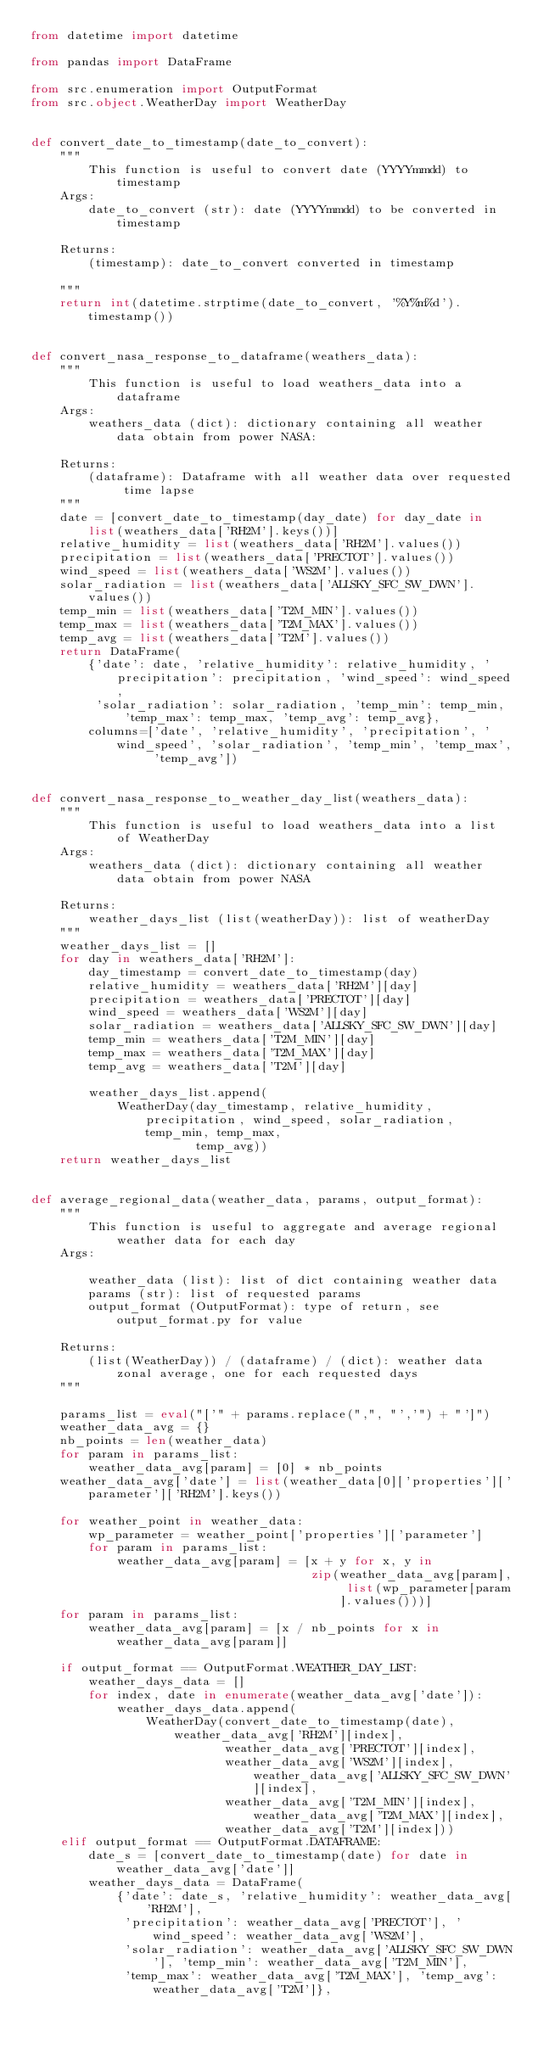<code> <loc_0><loc_0><loc_500><loc_500><_Python_>from datetime import datetime

from pandas import DataFrame

from src.enumeration import OutputFormat
from src.object.WeatherDay import WeatherDay


def convert_date_to_timestamp(date_to_convert):
    """
        This function is useful to convert date (YYYYmmdd) to timestamp
    Args:
        date_to_convert (str): date (YYYYmmdd) to be converted in timestamp

    Returns:
        (timestamp): date_to_convert converted in timestamp

    """
    return int(datetime.strptime(date_to_convert, '%Y%m%d').timestamp())


def convert_nasa_response_to_dataframe(weathers_data):
    """
        This function is useful to load weathers_data into a dataframe
    Args:
        weathers_data (dict): dictionary containing all weather data obtain from power NASA:

    Returns:
        (dataframe): Dataframe with all weather data over requested time lapse
    """
    date = [convert_date_to_timestamp(day_date) for day_date in list(weathers_data['RH2M'].keys())]
    relative_humidity = list(weathers_data['RH2M'].values())
    precipitation = list(weathers_data['PRECTOT'].values())
    wind_speed = list(weathers_data['WS2M'].values())
    solar_radiation = list(weathers_data['ALLSKY_SFC_SW_DWN'].values())
    temp_min = list(weathers_data['T2M_MIN'].values())
    temp_max = list(weathers_data['T2M_MAX'].values())
    temp_avg = list(weathers_data['T2M'].values())
    return DataFrame(
        {'date': date, 'relative_humidity': relative_humidity, 'precipitation': precipitation, 'wind_speed': wind_speed,
         'solar_radiation': solar_radiation, 'temp_min': temp_min, 'temp_max': temp_max, 'temp_avg': temp_avg},
        columns=['date', 'relative_humidity', 'precipitation', 'wind_speed', 'solar_radiation', 'temp_min', 'temp_max',
                 'temp_avg'])


def convert_nasa_response_to_weather_day_list(weathers_data):
    """
        This function is useful to load weathers_data into a list of WeatherDay
    Args:
        weathers_data (dict): dictionary containing all weather data obtain from power NASA

    Returns:
        weather_days_list (list(weatherDay)): list of weatherDay
    """
    weather_days_list = []
    for day in weathers_data['RH2M']:
        day_timestamp = convert_date_to_timestamp(day)
        relative_humidity = weathers_data['RH2M'][day]
        precipitation = weathers_data['PRECTOT'][day]
        wind_speed = weathers_data['WS2M'][day]
        solar_radiation = weathers_data['ALLSKY_SFC_SW_DWN'][day]
        temp_min = weathers_data['T2M_MIN'][day]
        temp_max = weathers_data['T2M_MAX'][day]
        temp_avg = weathers_data['T2M'][day]

        weather_days_list.append(
            WeatherDay(day_timestamp, relative_humidity, precipitation, wind_speed, solar_radiation, temp_min, temp_max,
                       temp_avg))
    return weather_days_list


def average_regional_data(weather_data, params, output_format):
    """
        This function is useful to aggregate and average regional weather data for each day
    Args:

        weather_data (list): list of dict containing weather data
        params (str): list of requested params
        output_format (OutputFormat): type of return, see output_format.py for value

    Returns:
        (list(WeatherDay)) / (dataframe) / (dict): weather data zonal average, one for each requested days
    """

    params_list = eval("['" + params.replace(",", "','") + "']")
    weather_data_avg = {}
    nb_points = len(weather_data)
    for param in params_list:
        weather_data_avg[param] = [0] * nb_points
    weather_data_avg['date'] = list(weather_data[0]['properties']['parameter']['RH2M'].keys())

    for weather_point in weather_data:
        wp_parameter = weather_point['properties']['parameter']
        for param in params_list:
            weather_data_avg[param] = [x + y for x, y in
                                       zip(weather_data_avg[param], list(wp_parameter[param].values()))]
    for param in params_list:
        weather_data_avg[param] = [x / nb_points for x in weather_data_avg[param]]

    if output_format == OutputFormat.WEATHER_DAY_LIST:
        weather_days_data = []
        for index, date in enumerate(weather_data_avg['date']):
            weather_days_data.append(
                WeatherDay(convert_date_to_timestamp(date), weather_data_avg['RH2M'][index],
                           weather_data_avg['PRECTOT'][index],
                           weather_data_avg['WS2M'][index], weather_data_avg['ALLSKY_SFC_SW_DWN'][index],
                           weather_data_avg['T2M_MIN'][index], weather_data_avg['T2M_MAX'][index],
                           weather_data_avg['T2M'][index]))
    elif output_format == OutputFormat.DATAFRAME:
        date_s = [convert_date_to_timestamp(date) for date in weather_data_avg['date']]
        weather_days_data = DataFrame(
            {'date': date_s, 'relative_humidity': weather_data_avg['RH2M'],
             'precipitation': weather_data_avg['PRECTOT'], 'wind_speed': weather_data_avg['WS2M'],
             'solar_radiation': weather_data_avg['ALLSKY_SFC_SW_DWN'], 'temp_min': weather_data_avg['T2M_MIN'],
             'temp_max': weather_data_avg['T2M_MAX'], 'temp_avg': weather_data_avg['T2M']},</code> 